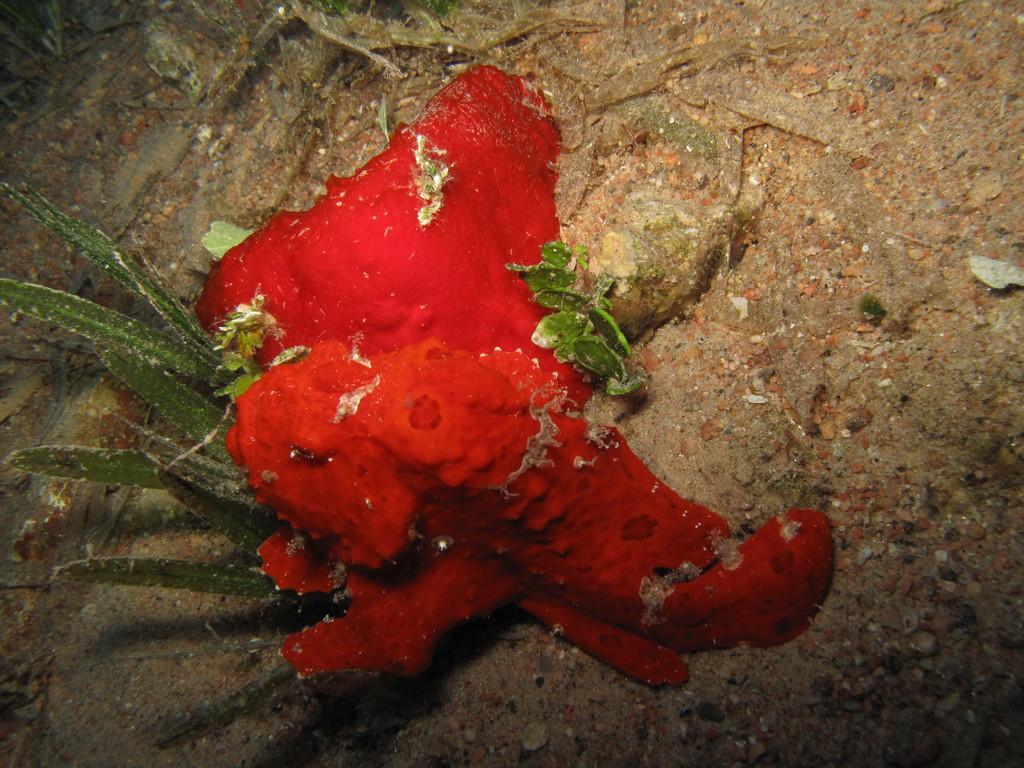Can you describe this image briefly? In this picture I can see a plant and a red color thing on the ground. 